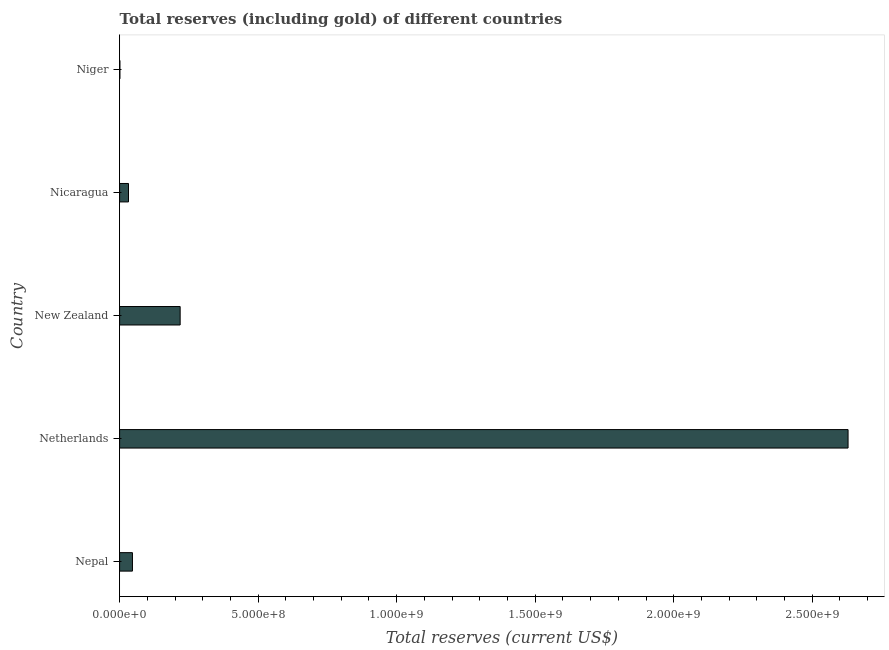What is the title of the graph?
Ensure brevity in your answer.  Total reserves (including gold) of different countries. What is the label or title of the X-axis?
Keep it short and to the point. Total reserves (current US$). What is the label or title of the Y-axis?
Keep it short and to the point. Country. What is the total reserves (including gold) in Nepal?
Your response must be concise. 4.64e+07. Across all countries, what is the maximum total reserves (including gold)?
Keep it short and to the point. 2.63e+09. Across all countries, what is the minimum total reserves (including gold)?
Provide a succinct answer. 1.10e+06. In which country was the total reserves (including gold) maximum?
Keep it short and to the point. Netherlands. In which country was the total reserves (including gold) minimum?
Provide a succinct answer. Niger. What is the sum of the total reserves (including gold)?
Your response must be concise. 2.93e+09. What is the difference between the total reserves (including gold) in Nicaragua and Niger?
Offer a very short reply. 3.10e+07. What is the average total reserves (including gold) per country?
Your response must be concise. 5.85e+08. What is the median total reserves (including gold)?
Provide a succinct answer. 4.64e+07. In how many countries, is the total reserves (including gold) greater than 1600000000 US$?
Keep it short and to the point. 1. What is the ratio of the total reserves (including gold) in Netherlands to that in New Zealand?
Provide a short and direct response. 12.03. Is the total reserves (including gold) in Nepal less than that in Nicaragua?
Ensure brevity in your answer.  No. What is the difference between the highest and the second highest total reserves (including gold)?
Your response must be concise. 2.41e+09. Is the sum of the total reserves (including gold) in Netherlands and New Zealand greater than the maximum total reserves (including gold) across all countries?
Your answer should be compact. Yes. What is the difference between the highest and the lowest total reserves (including gold)?
Provide a short and direct response. 2.63e+09. Are all the bars in the graph horizontal?
Keep it short and to the point. Yes. What is the difference between two consecutive major ticks on the X-axis?
Your answer should be compact. 5.00e+08. What is the Total reserves (current US$) in Nepal?
Keep it short and to the point. 4.64e+07. What is the Total reserves (current US$) of Netherlands?
Keep it short and to the point. 2.63e+09. What is the Total reserves (current US$) in New Zealand?
Make the answer very short. 2.19e+08. What is the Total reserves (current US$) in Nicaragua?
Make the answer very short. 3.21e+07. What is the Total reserves (current US$) of Niger?
Provide a short and direct response. 1.10e+06. What is the difference between the Total reserves (current US$) in Nepal and Netherlands?
Provide a short and direct response. -2.58e+09. What is the difference between the Total reserves (current US$) in Nepal and New Zealand?
Offer a terse response. -1.72e+08. What is the difference between the Total reserves (current US$) in Nepal and Nicaragua?
Provide a short and direct response. 1.43e+07. What is the difference between the Total reserves (current US$) in Nepal and Niger?
Give a very brief answer. 4.53e+07. What is the difference between the Total reserves (current US$) in Netherlands and New Zealand?
Ensure brevity in your answer.  2.41e+09. What is the difference between the Total reserves (current US$) in Netherlands and Nicaragua?
Make the answer very short. 2.60e+09. What is the difference between the Total reserves (current US$) in Netherlands and Niger?
Provide a succinct answer. 2.63e+09. What is the difference between the Total reserves (current US$) in New Zealand and Nicaragua?
Ensure brevity in your answer.  1.86e+08. What is the difference between the Total reserves (current US$) in New Zealand and Niger?
Your answer should be compact. 2.17e+08. What is the difference between the Total reserves (current US$) in Nicaragua and Niger?
Provide a short and direct response. 3.10e+07. What is the ratio of the Total reserves (current US$) in Nepal to that in Netherlands?
Your response must be concise. 0.02. What is the ratio of the Total reserves (current US$) in Nepal to that in New Zealand?
Keep it short and to the point. 0.21. What is the ratio of the Total reserves (current US$) in Nepal to that in Nicaragua?
Your answer should be compact. 1.45. What is the ratio of the Total reserves (current US$) in Nepal to that in Niger?
Provide a short and direct response. 42.17. What is the ratio of the Total reserves (current US$) in Netherlands to that in New Zealand?
Give a very brief answer. 12.03. What is the ratio of the Total reserves (current US$) in Netherlands to that in Nicaragua?
Your answer should be very brief. 81.93. What is the ratio of the Total reserves (current US$) in Netherlands to that in Niger?
Offer a very short reply. 2390.19. What is the ratio of the Total reserves (current US$) in New Zealand to that in Nicaragua?
Make the answer very short. 6.81. What is the ratio of the Total reserves (current US$) in New Zealand to that in Niger?
Offer a terse response. 198.69. What is the ratio of the Total reserves (current US$) in Nicaragua to that in Niger?
Ensure brevity in your answer.  29.17. 